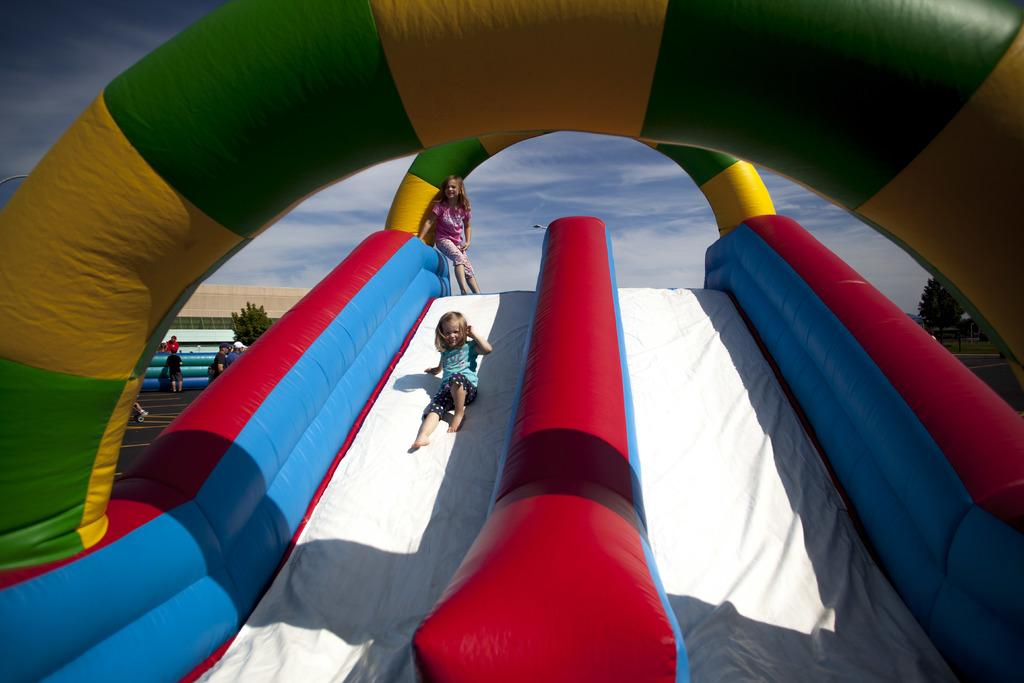What type of play equipment is featured in the image? There are inflatable balloon slides in the image. Who is using the slides in the image? Two small girls are sliding on the slides. What can be seen at the top of the image? The sky is visible at the top of the image. What type of rhythm is the leg performing in the image? There is no leg or rhythm present in the image; it features inflatable balloon slides and two small girls sliding on them. 